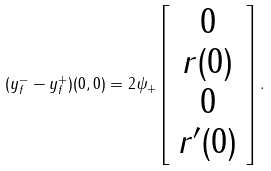<formula> <loc_0><loc_0><loc_500><loc_500>( y _ { f } ^ { - } - y _ { f } ^ { + } ) ( 0 , 0 ) = 2 \psi _ { + } \left [ \begin{array} { c } 0 \\ r ( 0 ) \\ 0 \\ r ^ { \prime } ( 0 ) \end{array} \right ] .</formula> 